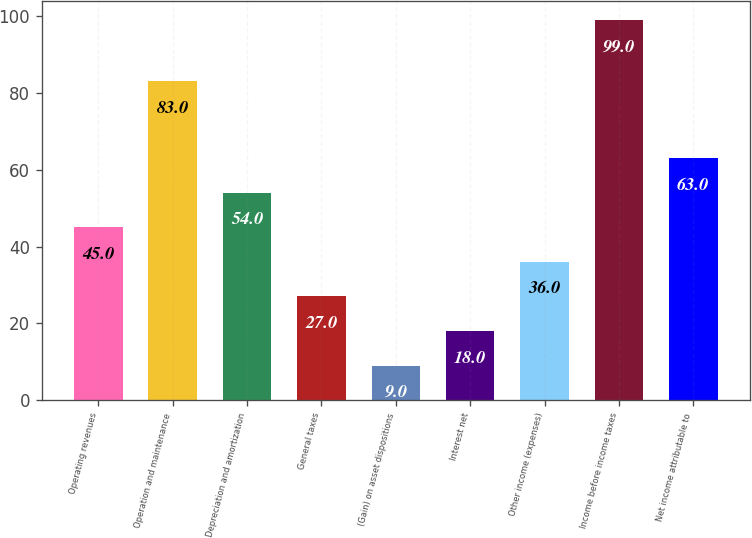Convert chart to OTSL. <chart><loc_0><loc_0><loc_500><loc_500><bar_chart><fcel>Operating revenues<fcel>Operation and maintenance<fcel>Depreciation and amortization<fcel>General taxes<fcel>(Gain) on asset dispositions<fcel>Interest net<fcel>Other income (expenses)<fcel>Income before income taxes<fcel>Net income attributable to<nl><fcel>45<fcel>83<fcel>54<fcel>27<fcel>9<fcel>18<fcel>36<fcel>99<fcel>63<nl></chart> 